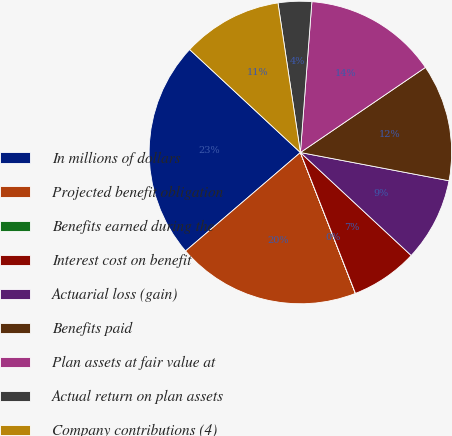Convert chart to OTSL. <chart><loc_0><loc_0><loc_500><loc_500><pie_chart><fcel>In millions of dollars<fcel>Projected benefit obligation<fcel>Benefits earned during the<fcel>Interest cost on benefit<fcel>Actuarial loss (gain)<fcel>Benefits paid<fcel>Plan assets at fair value at<fcel>Actual return on plan assets<fcel>Company contributions (4)<nl><fcel>23.2%<fcel>19.64%<fcel>0.01%<fcel>7.15%<fcel>8.93%<fcel>12.5%<fcel>14.28%<fcel>3.58%<fcel>10.71%<nl></chart> 